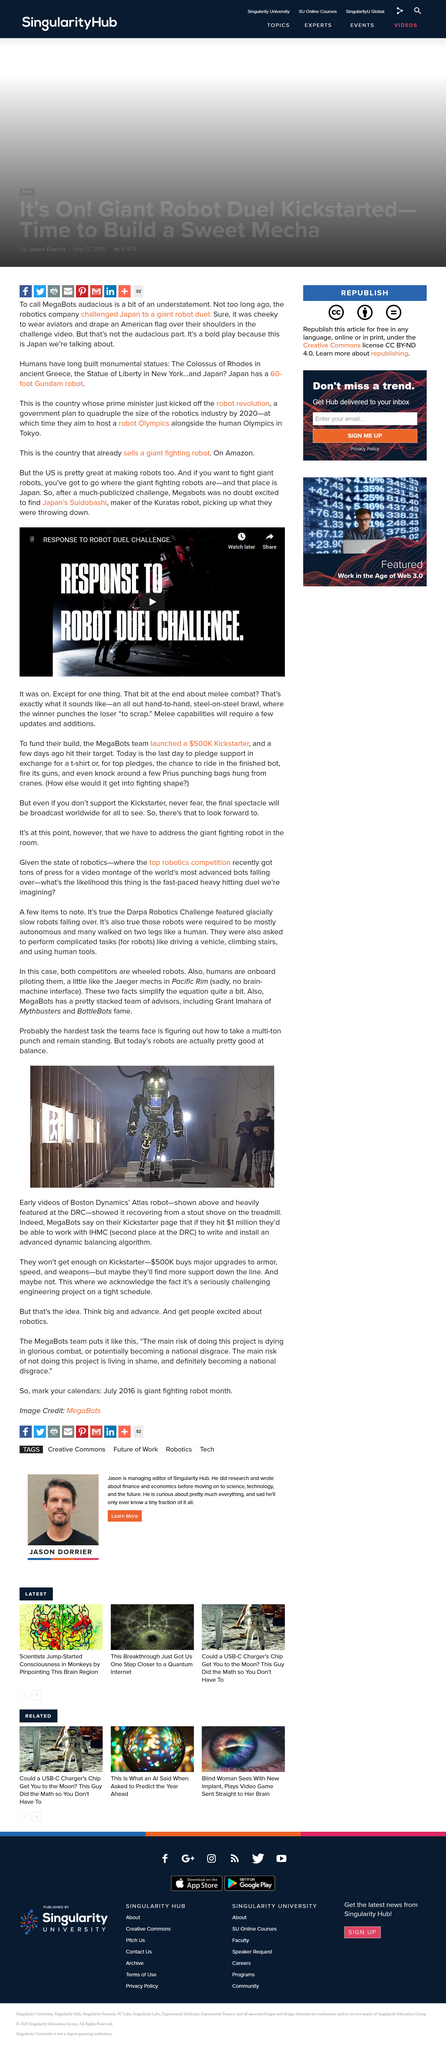Mention a couple of crucial points in this snapshot. Early videos of Boston Dynamics' Atlas robot demonstrate its ability to recover from a sturdy shove on the treadmill, while the most challenging task for teams is to enable the robot to withstand a multi-punch attack and remain standing without tumbling or losing balance. If MegaBots reach their fundraising goal of $1 million on their Kickstarter page, they will be able to collaborate with the Institute for Human and Machine Cognition (IHMC). Grant Imahara is one of MegaBots' advisors. 